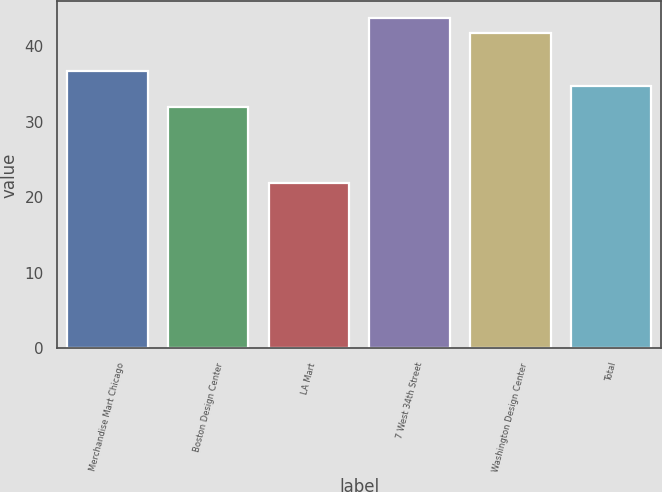<chart> <loc_0><loc_0><loc_500><loc_500><bar_chart><fcel>Merchandise Mart Chicago<fcel>Boston Design Center<fcel>LA Mart<fcel>7 West 34th Street<fcel>Washington Design Center<fcel>Total<nl><fcel>36.7<fcel>31.96<fcel>21.89<fcel>43.74<fcel>41.73<fcel>34.68<nl></chart> 